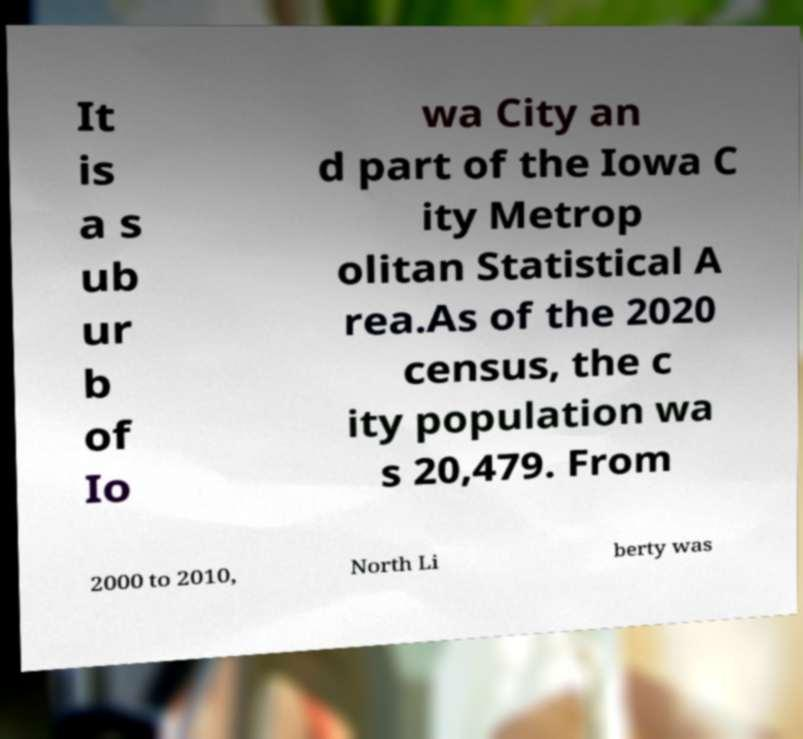Can you read and provide the text displayed in the image?This photo seems to have some interesting text. Can you extract and type it out for me? It is a s ub ur b of Io wa City an d part of the Iowa C ity Metrop olitan Statistical A rea.As of the 2020 census, the c ity population wa s 20,479. From 2000 to 2010, North Li berty was 